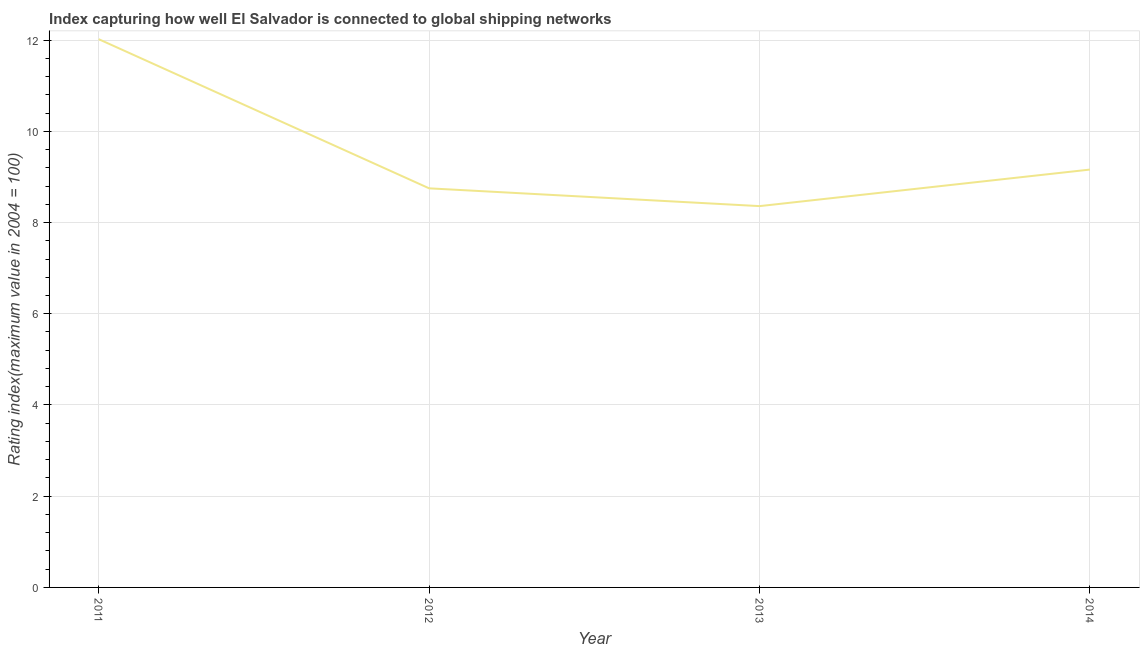What is the liner shipping connectivity index in 2011?
Your answer should be very brief. 12.02. Across all years, what is the maximum liner shipping connectivity index?
Offer a terse response. 12.02. Across all years, what is the minimum liner shipping connectivity index?
Your response must be concise. 8.36. What is the sum of the liner shipping connectivity index?
Make the answer very short. 38.29. What is the difference between the liner shipping connectivity index in 2012 and 2013?
Give a very brief answer. 0.39. What is the average liner shipping connectivity index per year?
Offer a terse response. 9.57. What is the median liner shipping connectivity index?
Make the answer very short. 8.96. Do a majority of the years between 2012 and 2014 (inclusive) have liner shipping connectivity index greater than 4 ?
Your answer should be compact. Yes. What is the ratio of the liner shipping connectivity index in 2011 to that in 2014?
Offer a terse response. 1.31. Is the difference between the liner shipping connectivity index in 2011 and 2013 greater than the difference between any two years?
Ensure brevity in your answer.  Yes. What is the difference between the highest and the second highest liner shipping connectivity index?
Your answer should be very brief. 2.86. Is the sum of the liner shipping connectivity index in 2011 and 2014 greater than the maximum liner shipping connectivity index across all years?
Your answer should be compact. Yes. What is the difference between the highest and the lowest liner shipping connectivity index?
Your answer should be very brief. 3.66. How many lines are there?
Offer a very short reply. 1. Are the values on the major ticks of Y-axis written in scientific E-notation?
Your answer should be compact. No. What is the title of the graph?
Ensure brevity in your answer.  Index capturing how well El Salvador is connected to global shipping networks. What is the label or title of the X-axis?
Offer a terse response. Year. What is the label or title of the Y-axis?
Make the answer very short. Rating index(maximum value in 2004 = 100). What is the Rating index(maximum value in 2004 = 100) in 2011?
Provide a short and direct response. 12.02. What is the Rating index(maximum value in 2004 = 100) in 2012?
Your answer should be very brief. 8.75. What is the Rating index(maximum value in 2004 = 100) in 2013?
Provide a short and direct response. 8.36. What is the Rating index(maximum value in 2004 = 100) of 2014?
Your answer should be very brief. 9.16. What is the difference between the Rating index(maximum value in 2004 = 100) in 2011 and 2012?
Provide a short and direct response. 3.27. What is the difference between the Rating index(maximum value in 2004 = 100) in 2011 and 2013?
Your response must be concise. 3.66. What is the difference between the Rating index(maximum value in 2004 = 100) in 2011 and 2014?
Provide a short and direct response. 2.86. What is the difference between the Rating index(maximum value in 2004 = 100) in 2012 and 2013?
Give a very brief answer. 0.39. What is the difference between the Rating index(maximum value in 2004 = 100) in 2012 and 2014?
Provide a succinct answer. -0.41. What is the difference between the Rating index(maximum value in 2004 = 100) in 2013 and 2014?
Your answer should be compact. -0.8. What is the ratio of the Rating index(maximum value in 2004 = 100) in 2011 to that in 2012?
Keep it short and to the point. 1.37. What is the ratio of the Rating index(maximum value in 2004 = 100) in 2011 to that in 2013?
Your answer should be compact. 1.44. What is the ratio of the Rating index(maximum value in 2004 = 100) in 2011 to that in 2014?
Give a very brief answer. 1.31. What is the ratio of the Rating index(maximum value in 2004 = 100) in 2012 to that in 2013?
Provide a succinct answer. 1.05. What is the ratio of the Rating index(maximum value in 2004 = 100) in 2012 to that in 2014?
Provide a short and direct response. 0.95. What is the ratio of the Rating index(maximum value in 2004 = 100) in 2013 to that in 2014?
Make the answer very short. 0.91. 